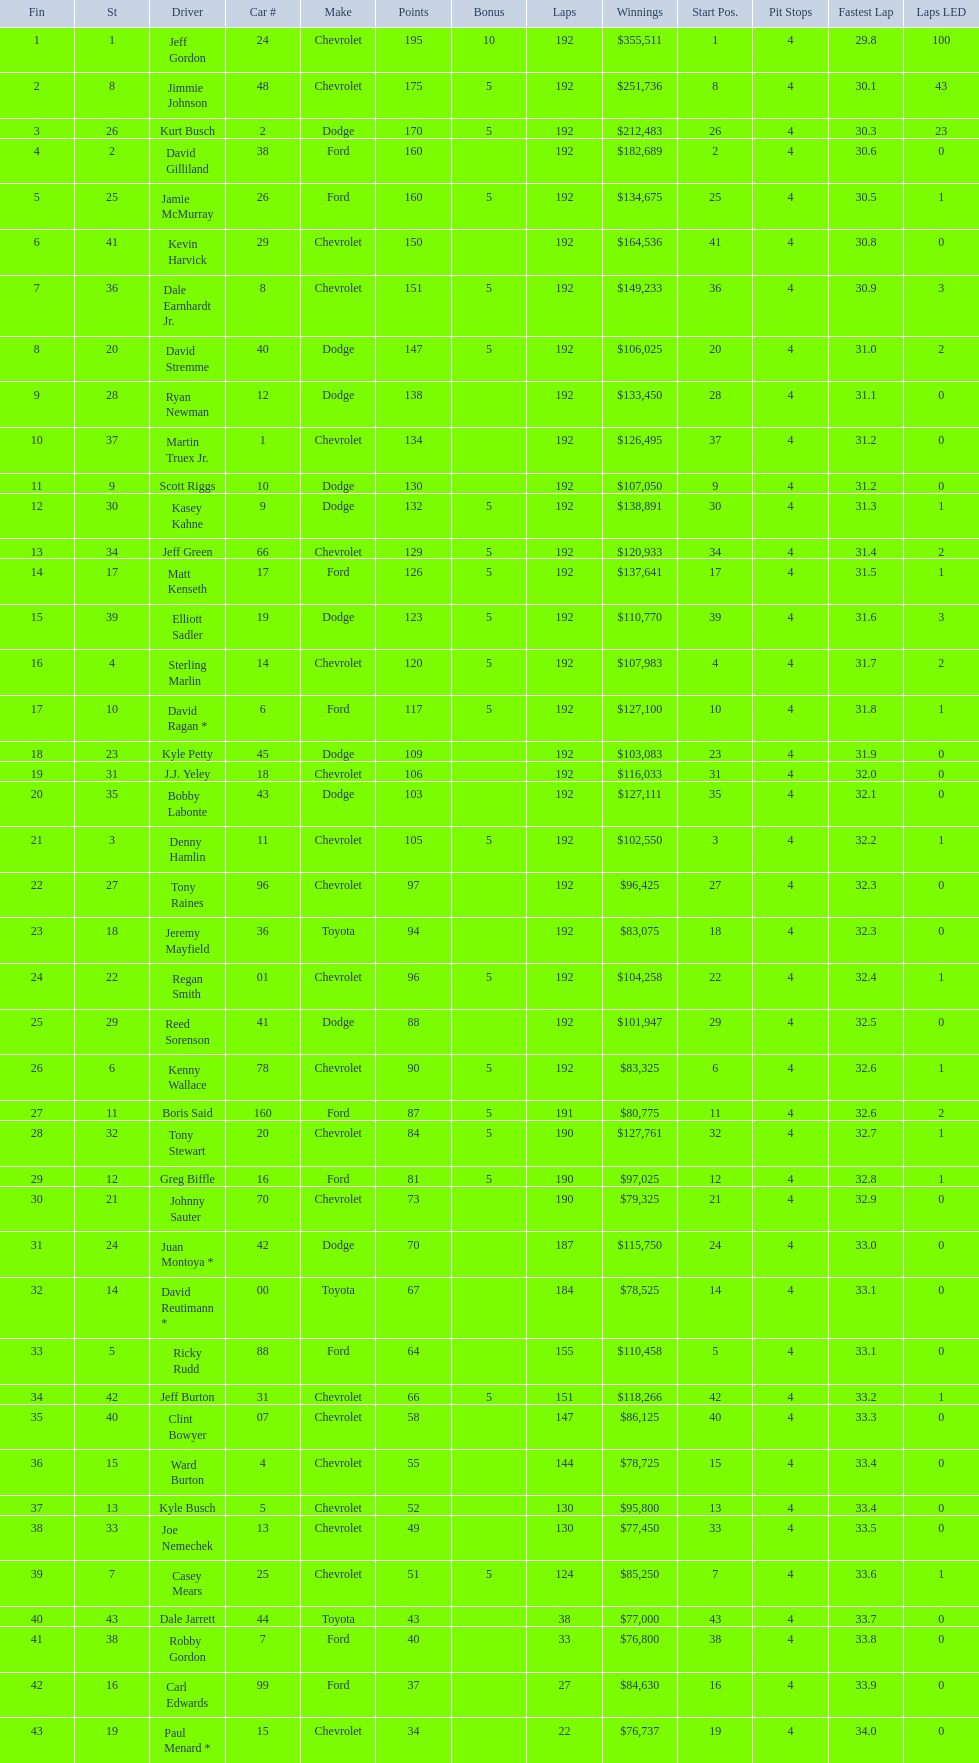How many drivers earned 5 bonus each in the race? 19. 